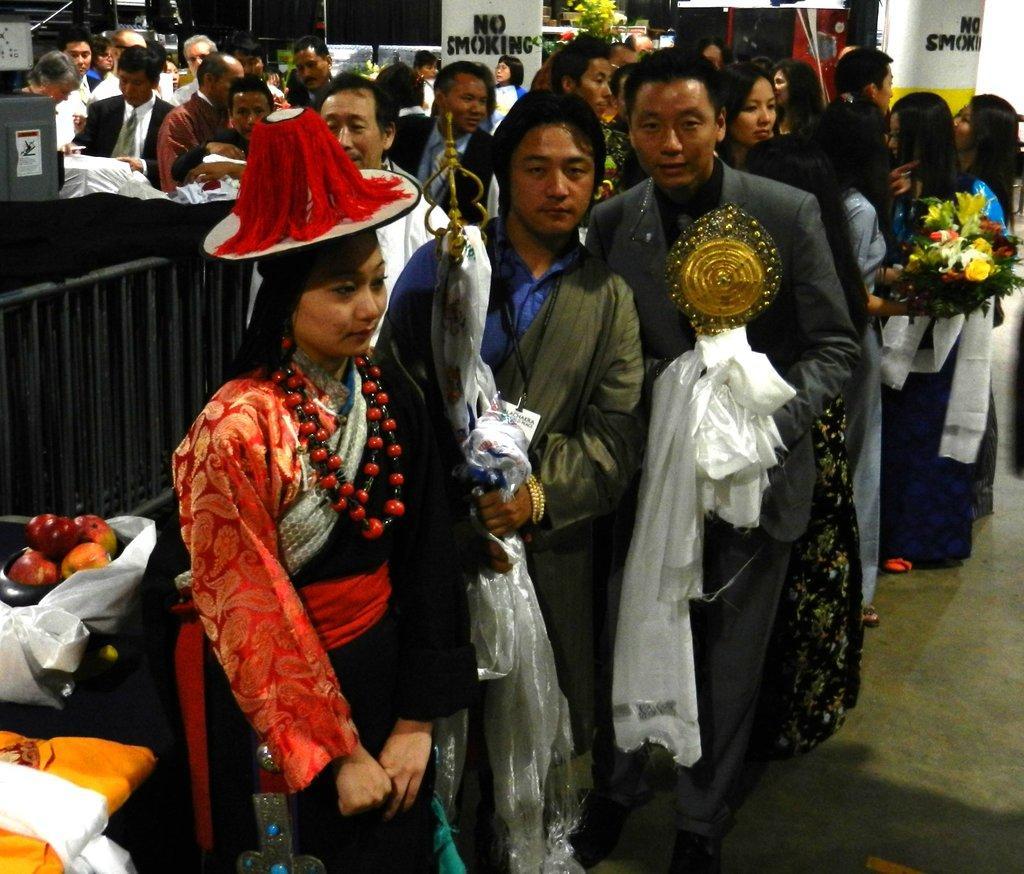Describe this image in one or two sentences. In this picture there is a group of men standing in front holding some awards in the hand, smiling and giving pose into the camera. Beside there is a Chinese girl wearing a traditional dress with cap is looking on the right side. In the background there is a glass wall and some persons standing in the ques. 